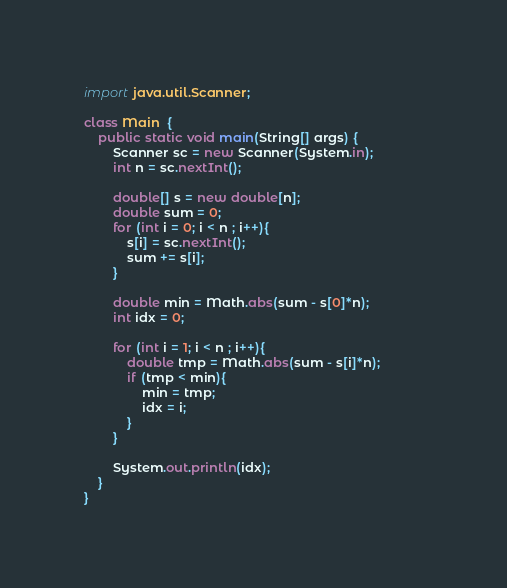<code> <loc_0><loc_0><loc_500><loc_500><_Java_>import java.util.Scanner;
 
class Main  {
    public static void main(String[] args) {
        Scanner sc = new Scanner(System.in);
        int n = sc.nextInt();
 
        double[] s = new double[n];
        double sum = 0;
        for (int i = 0; i < n ; i++){
            s[i] = sc.nextInt();
            sum += s[i];
        }
 
        double min = Math.abs(sum - s[0]*n);
        int idx = 0;
 
        for (int i = 1; i < n ; i++){
            double tmp = Math.abs(sum - s[i]*n);            
            if (tmp < min){
                min = tmp;
                idx = i;
            }
        }
 
        System.out.println(idx);
    }
}</code> 